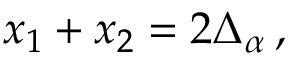Convert formula to latex. <formula><loc_0><loc_0><loc_500><loc_500>x _ { 1 } + x _ { 2 } = 2 \Delta _ { \alpha } \, ,</formula> 